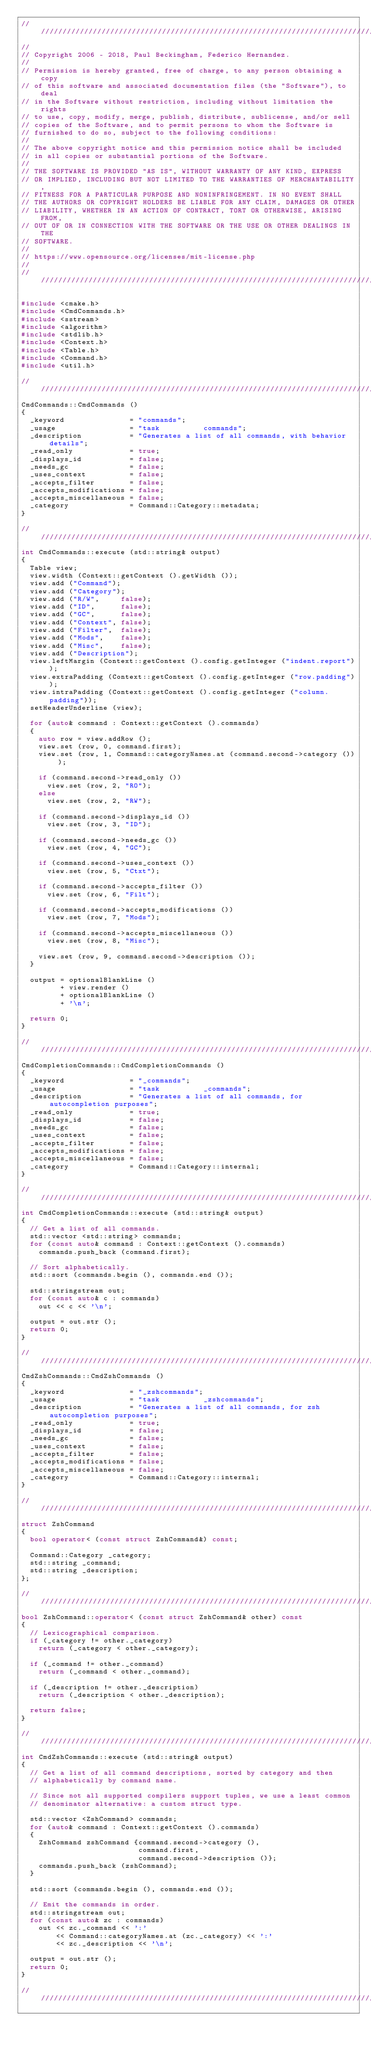Convert code to text. <code><loc_0><loc_0><loc_500><loc_500><_C++_>////////////////////////////////////////////////////////////////////////////////
//
// Copyright 2006 - 2018, Paul Beckingham, Federico Hernandez.
//
// Permission is hereby granted, free of charge, to any person obtaining a copy
// of this software and associated documentation files (the "Software"), to deal
// in the Software without restriction, including without limitation the rights
// to use, copy, modify, merge, publish, distribute, sublicense, and/or sell
// copies of the Software, and to permit persons to whom the Software is
// furnished to do so, subject to the following conditions:
//
// The above copyright notice and this permission notice shall be included
// in all copies or substantial portions of the Software.
//
// THE SOFTWARE IS PROVIDED "AS IS", WITHOUT WARRANTY OF ANY KIND, EXPRESS
// OR IMPLIED, INCLUDING BUT NOT LIMITED TO THE WARRANTIES OF MERCHANTABILITY,
// FITNESS FOR A PARTICULAR PURPOSE AND NONINFRINGEMENT. IN NO EVENT SHALL
// THE AUTHORS OR COPYRIGHT HOLDERS BE LIABLE FOR ANY CLAIM, DAMAGES OR OTHER
// LIABILITY, WHETHER IN AN ACTION OF CONTRACT, TORT OR OTHERWISE, ARISING FROM,
// OUT OF OR IN CONNECTION WITH THE SOFTWARE OR THE USE OR OTHER DEALINGS IN THE
// SOFTWARE.
//
// https://www.opensource.org/licenses/mit-license.php
//
////////////////////////////////////////////////////////////////////////////////

#include <cmake.h>
#include <CmdCommands.h>
#include <sstream>
#include <algorithm>
#include <stdlib.h>
#include <Context.h>
#include <Table.h>
#include <Command.h>
#include <util.h>

////////////////////////////////////////////////////////////////////////////////
CmdCommands::CmdCommands ()
{
  _keyword               = "commands";
  _usage                 = "task          commands";
  _description           = "Generates a list of all commands, with behavior details";
  _read_only             = true;
  _displays_id           = false;
  _needs_gc              = false;
  _uses_context          = false;
  _accepts_filter        = false;
  _accepts_modifications = false;
  _accepts_miscellaneous = false;
  _category              = Command::Category::metadata;
}

////////////////////////////////////////////////////////////////////////////////
int CmdCommands::execute (std::string& output)
{
  Table view;
  view.width (Context::getContext ().getWidth ());
  view.add ("Command");
  view.add ("Category");
  view.add ("R/W",     false);
  view.add ("ID",      false);
  view.add ("GC",      false);
  view.add ("Context", false);
  view.add ("Filter",  false);
  view.add ("Mods",    false);
  view.add ("Misc",    false);
  view.add ("Description");
  view.leftMargin (Context::getContext ().config.getInteger ("indent.report"));
  view.extraPadding (Context::getContext ().config.getInteger ("row.padding"));
  view.intraPadding (Context::getContext ().config.getInteger ("column.padding"));
  setHeaderUnderline (view);

  for (auto& command : Context::getContext ().commands)
  {
    auto row = view.addRow ();
    view.set (row, 0, command.first);
    view.set (row, 1, Command::categoryNames.at (command.second->category ()));

    if (command.second->read_only ())
      view.set (row, 2, "RO");
    else
      view.set (row, 2, "RW");

    if (command.second->displays_id ())
      view.set (row, 3, "ID");

    if (command.second->needs_gc ())
      view.set (row, 4, "GC");

    if (command.second->uses_context ())
      view.set (row, 5, "Ctxt");

    if (command.second->accepts_filter ())
      view.set (row, 6, "Filt");

    if (command.second->accepts_modifications ())
      view.set (row, 7, "Mods");

    if (command.second->accepts_miscellaneous ())
      view.set (row, 8, "Misc");

    view.set (row, 9, command.second->description ());
  }

  output = optionalBlankLine ()
         + view.render ()
         + optionalBlankLine ()
         + '\n';

  return 0;
}

////////////////////////////////////////////////////////////////////////////////
CmdCompletionCommands::CmdCompletionCommands ()
{
  _keyword               = "_commands";
  _usage                 = "task          _commands";
  _description           = "Generates a list of all commands, for autocompletion purposes";
  _read_only             = true;
  _displays_id           = false;
  _needs_gc              = false;
  _uses_context          = false;
  _accepts_filter        = false;
  _accepts_modifications = false;
  _accepts_miscellaneous = false;
  _category              = Command::Category::internal;
}

////////////////////////////////////////////////////////////////////////////////
int CmdCompletionCommands::execute (std::string& output)
{
  // Get a list of all commands.
  std::vector <std::string> commands;
  for (const auto& command : Context::getContext ().commands)
    commands.push_back (command.first);

  // Sort alphabetically.
  std::sort (commands.begin (), commands.end ());

  std::stringstream out;
  for (const auto& c : commands)
    out << c << '\n';

  output = out.str ();
  return 0;
}

////////////////////////////////////////////////////////////////////////////////
CmdZshCommands::CmdZshCommands ()
{
  _keyword               = "_zshcommands";
  _usage                 = "task          _zshcommands";
  _description           = "Generates a list of all commands, for zsh autocompletion purposes";
  _read_only             = true;
  _displays_id           = false;
  _needs_gc              = false;
  _uses_context          = false;
  _accepts_filter        = false;
  _accepts_modifications = false;
  _accepts_miscellaneous = false;
  _category              = Command::Category::internal;
}

////////////////////////////////////////////////////////////////////////////////
struct ZshCommand
{
  bool operator< (const struct ZshCommand&) const;

  Command::Category _category;
  std::string _command;
  std::string _description;
};

////////////////////////////////////////////////////////////////////////////////
bool ZshCommand::operator< (const struct ZshCommand& other) const
{
  // Lexicographical comparison.
  if (_category != other._category)
    return (_category < other._category);

  if (_command != other._command)
    return (_command < other._command);

  if (_description != other._description)
    return (_description < other._description);

  return false;
}

////////////////////////////////////////////////////////////////////////////////
int CmdZshCommands::execute (std::string& output)
{
  // Get a list of all command descriptions, sorted by category and then
  // alphabetically by command name.

  // Since not all supported compilers support tuples, we use a least common
  // denominator alternative: a custom struct type.

  std::vector <ZshCommand> commands;
  for (auto& command : Context::getContext ().commands)
  {
    ZshCommand zshCommand {command.second->category (),
                           command.first,
                           command.second->description ()};
    commands.push_back (zshCommand);
  }

  std::sort (commands.begin (), commands.end ());

  // Emit the commands in order.
  std::stringstream out;
  for (const auto& zc : commands)
    out << zc._command << ':'
        << Command::categoryNames.at (zc._category) << ':'
        << zc._description << '\n';

  output = out.str ();
  return 0;
}

////////////////////////////////////////////////////////////////////////////////
</code> 